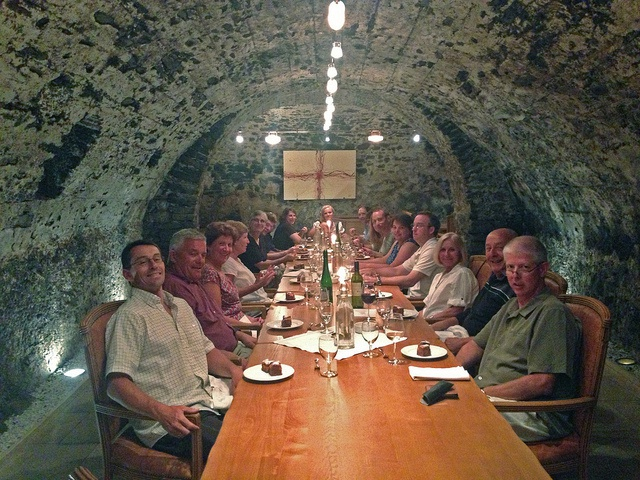Describe the objects in this image and their specific colors. I can see dining table in black, brown, tan, and red tones, people in black and gray tones, people in black, gray, and maroon tones, chair in black, gray, and maroon tones, and chair in black, maroon, and brown tones in this image. 